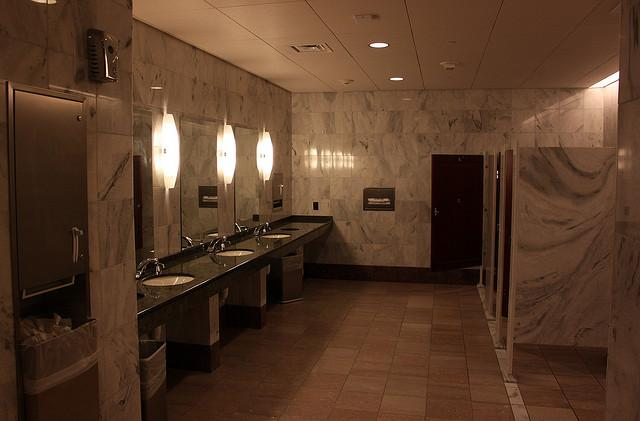What material is the tile for the walls and stalls of this bathroom? Please explain your reasoning. marble. The material is marble. 